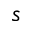Convert formula to latex. <formula><loc_0><loc_0><loc_500><loc_500>s</formula> 